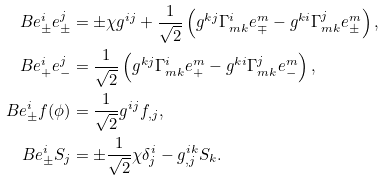<formula> <loc_0><loc_0><loc_500><loc_500>\L B { e ^ { i } _ { \pm } } { e ^ { j } _ { \pm } } & = \pm \chi g ^ { i j } + \frac { 1 } { \sqrt { 2 } } \left ( g ^ { k j } \Gamma ^ { i } _ { m k } e _ { \mp } ^ { m } - g ^ { k i } \Gamma ^ { j } _ { m k } e _ { \pm } ^ { m } \right ) , \\ \L B { e ^ { i } _ { + } } { e ^ { j } _ { - } } & = \frac { 1 } { \sqrt { 2 } } \left ( g ^ { k j } \Gamma ^ { i } _ { m k } e _ { + } ^ { m } - g ^ { k i } \Gamma ^ { j } _ { m k } e _ { - } ^ { m } \right ) , \\ \L B { e ^ { i } _ { \pm } } { f ( \phi ) } & = \frac { 1 } { \sqrt { 2 } } g ^ { i j } f _ { , j } , \\ \L B { e ^ { i } _ { \pm } } { S _ { j } } & = \pm \frac { 1 } { \sqrt { 2 } } \chi \delta ^ { i } _ { j } - g ^ { i k } _ { , j } S _ { k } .</formula> 